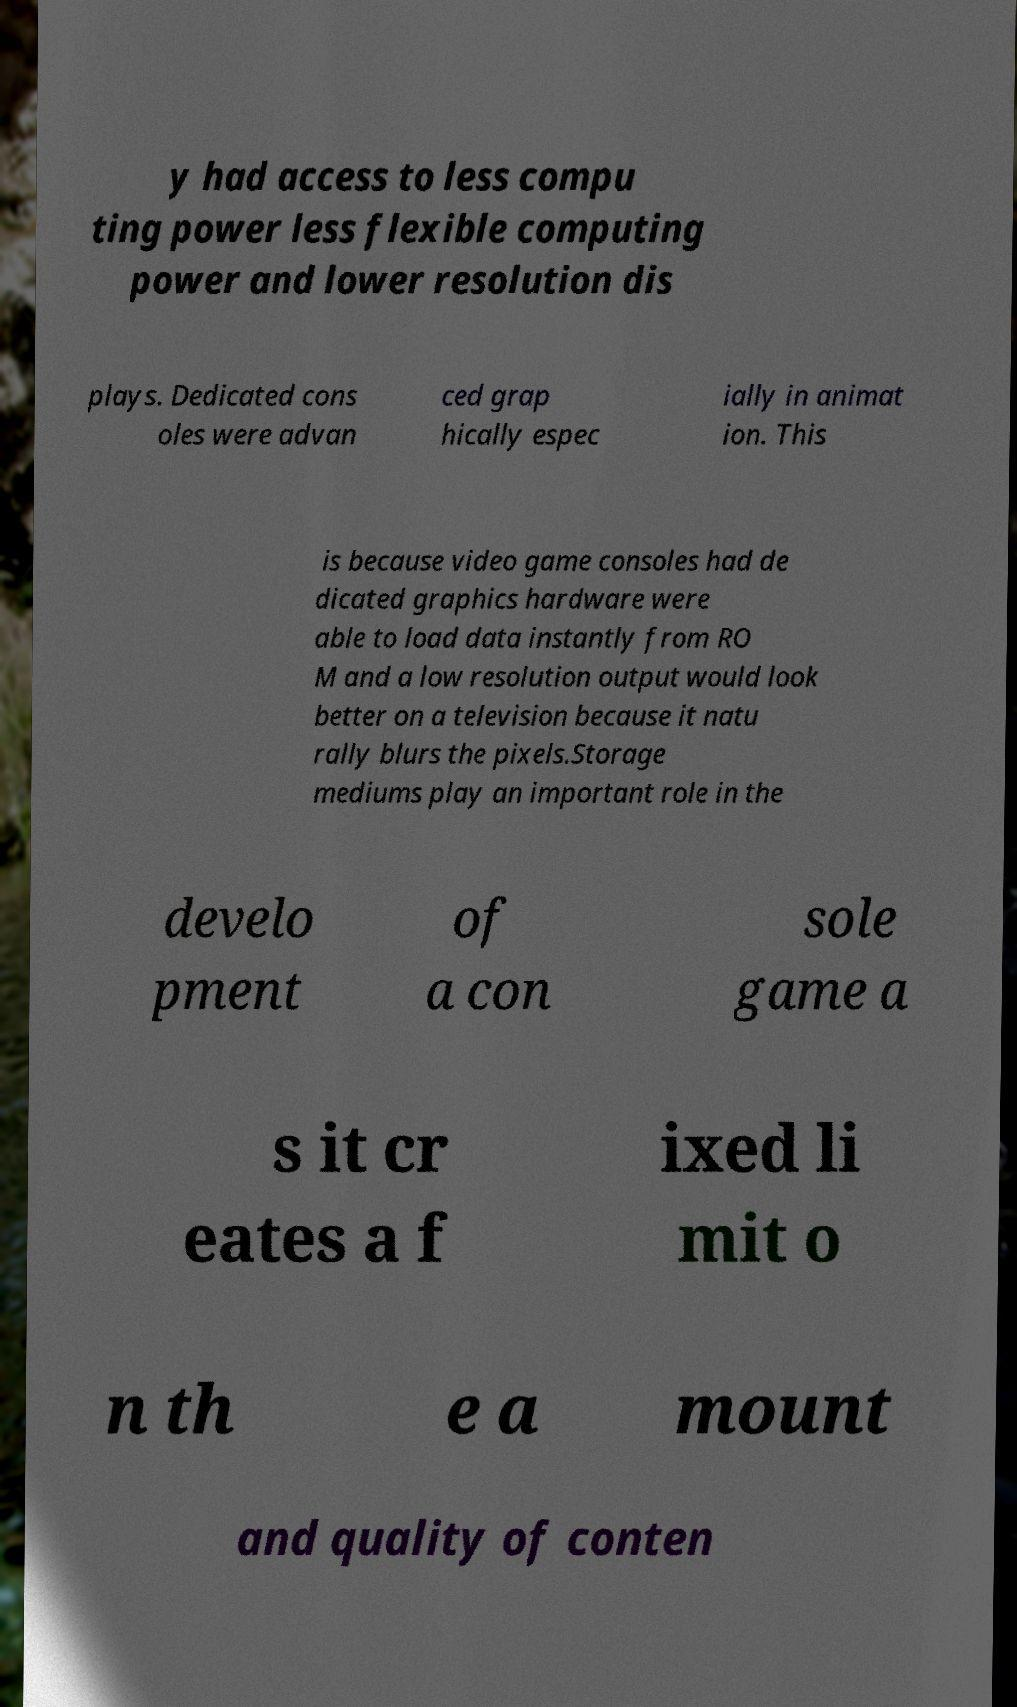I need the written content from this picture converted into text. Can you do that? y had access to less compu ting power less flexible computing power and lower resolution dis plays. Dedicated cons oles were advan ced grap hically espec ially in animat ion. This is because video game consoles had de dicated graphics hardware were able to load data instantly from RO M and a low resolution output would look better on a television because it natu rally blurs the pixels.Storage mediums play an important role in the develo pment of a con sole game a s it cr eates a f ixed li mit o n th e a mount and quality of conten 